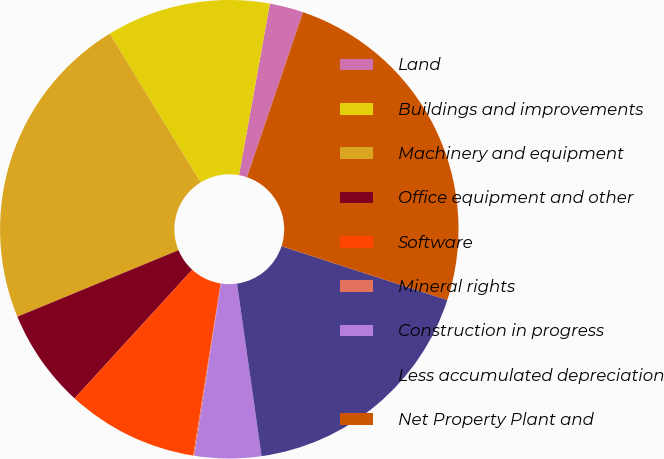Convert chart to OTSL. <chart><loc_0><loc_0><loc_500><loc_500><pie_chart><fcel>Land<fcel>Buildings and improvements<fcel>Machinery and equipment<fcel>Office equipment and other<fcel>Software<fcel>Mineral rights<fcel>Construction in progress<fcel>Less accumulated depreciation<fcel>Net Property Plant and<nl><fcel>2.38%<fcel>11.57%<fcel>22.5%<fcel>6.98%<fcel>9.28%<fcel>0.08%<fcel>4.68%<fcel>17.76%<fcel>24.79%<nl></chart> 